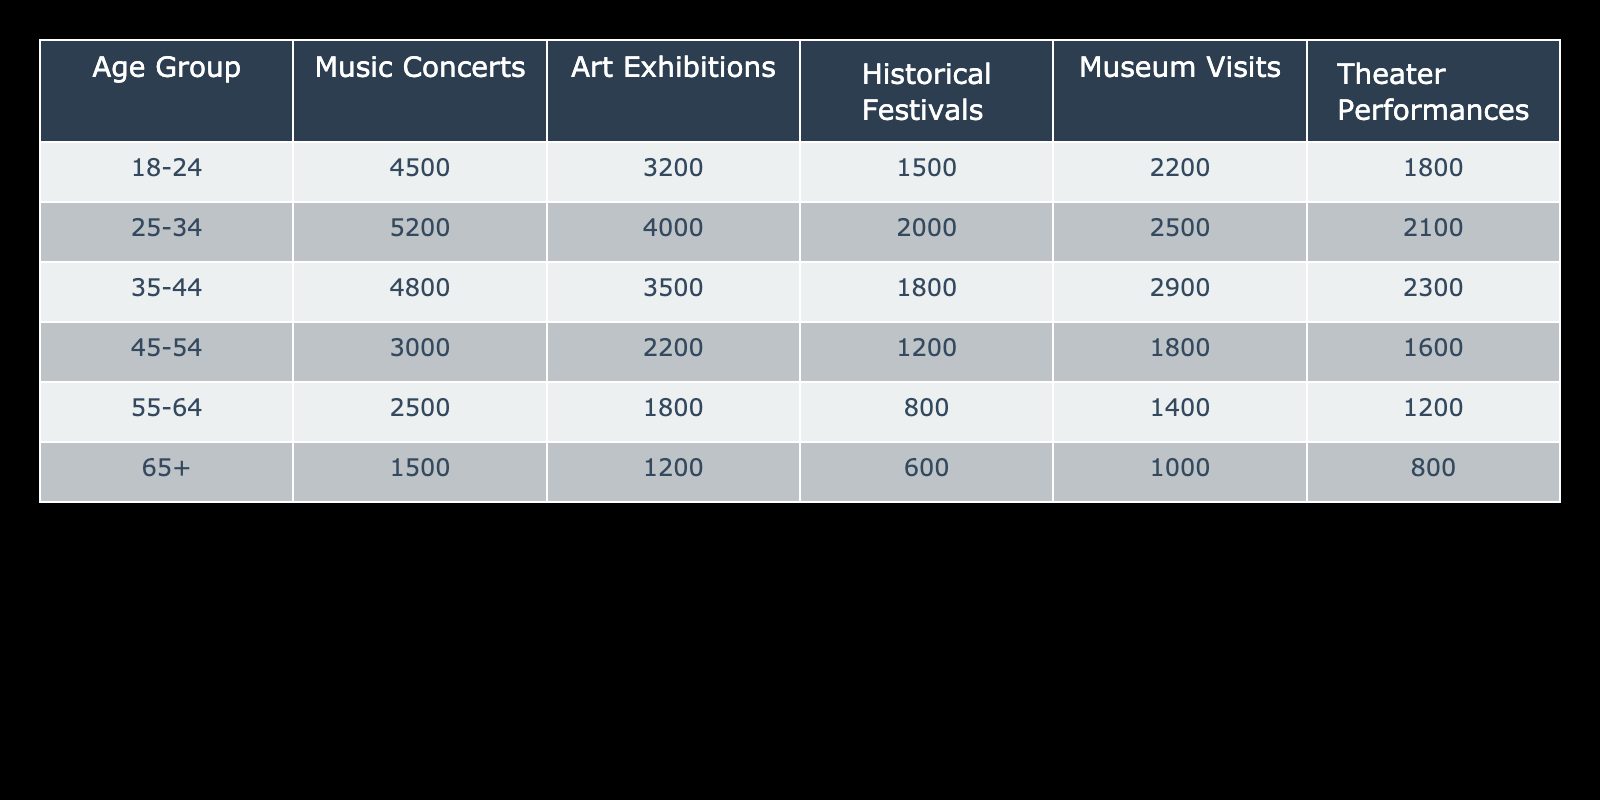What age group has the highest attendance at Historical Festivals? The age group with the highest attendance at Historical Festivals is 25-34, with a total of 2000 attendees.
Answer: 25-34 How many people attended Theater Performances in the 55-64 age group? The attendance for Theater Performances in the 55-64 age group is 1200.
Answer: 1200 What is the total attendance for Museum Visits across all age groups? To find the total attendance for Museum Visits, we sum the individual attendances: 2200 + 2500 + 2900 + 1800 + 1400 + 1000 = 11800.
Answer: 11800 Is it true that more people attended Art Exhibitions than Historical Festivals in the 35-44 age group? For the 35-44 age group, 3500 attended Art Exhibitions and 1800 attended Historical Festivals. Since 3500 is greater than 1800, the statement is true.
Answer: Yes What age group shows the lowest attendance across all event types? To find the age group with the lowest total attendance, we add up the attendances for each age group: 18-24 (4500 + 3200 + 1500 + 2200 + 1800 = 15700), 25-34 (5200 + 4000 + 2000 + 2500 + 2100 = 15800), 35-44 (4800 + 3500 + 1800 + 2900 + 2300 = 19300), 45-54 (3000 + 2200 + 1200 + 1800 + 1600 = 10800), 55-64 (2500 + 1800 + 800 + 1400 + 1200 = 7700), 65+ (1500 + 1200 + 600 + 1000 + 800 = 4100). The lowest total attendance is for the 65+ age group with 4100.
Answer: 65+ What is the average attendance for Music Concerts across all age groups? To find the average attendance for Music Concerts, we add the attendances: 4500 + 5200 + 4800 + 3000 + 2500 + 1500 = 22500. We then divide by the number of age groups (6) to calculate the average: 22500 / 6 = 3750.
Answer: 3750 